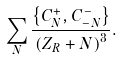Convert formula to latex. <formula><loc_0><loc_0><loc_500><loc_500>\sum _ { N } { \frac { \left \{ C _ { N } ^ { + } , C _ { - N } ^ { - } \right \} } { \left ( Z _ { R } + N \right ) ^ { 3 } } } .</formula> 